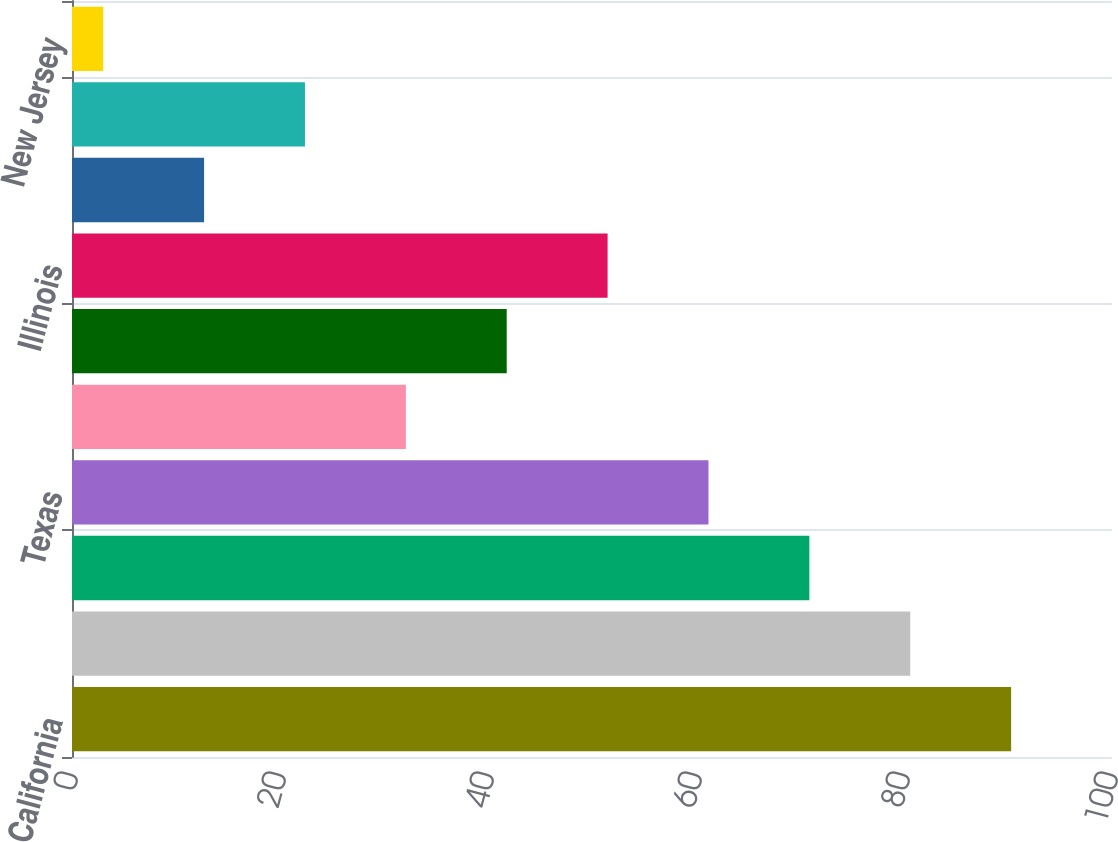Convert chart to OTSL. <chart><loc_0><loc_0><loc_500><loc_500><bar_chart><fcel>California<fcel>Florida<fcel>Maryland<fcel>Texas<fcel>Virginia<fcel>Pennsylvania<fcel>Illinois<fcel>New York<fcel>Ohio<fcel>New Jersey<nl><fcel>90.3<fcel>80.6<fcel>70.9<fcel>61.2<fcel>32.1<fcel>41.8<fcel>51.5<fcel>12.7<fcel>22.4<fcel>3<nl></chart> 